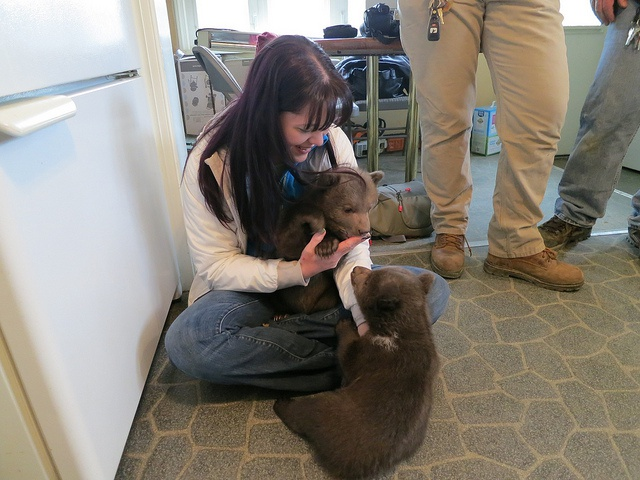Describe the objects in this image and their specific colors. I can see refrigerator in white, lightgray, darkgray, tan, and lightblue tones, people in white, black, gray, darkgray, and tan tones, people in white, tan, gray, and maroon tones, bear in white, black, maroon, and gray tones, and people in white, gray, and black tones in this image. 